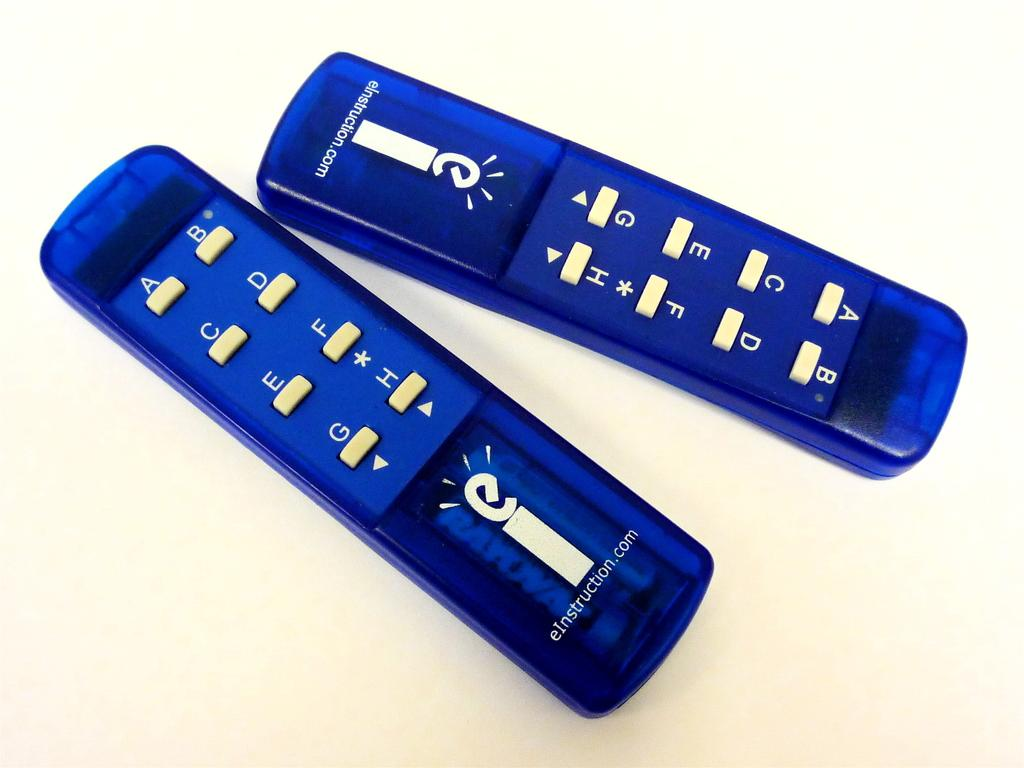<image>
Describe the image concisely. A pair of bright blue plastic remote controls are products from eInstruction.com. 